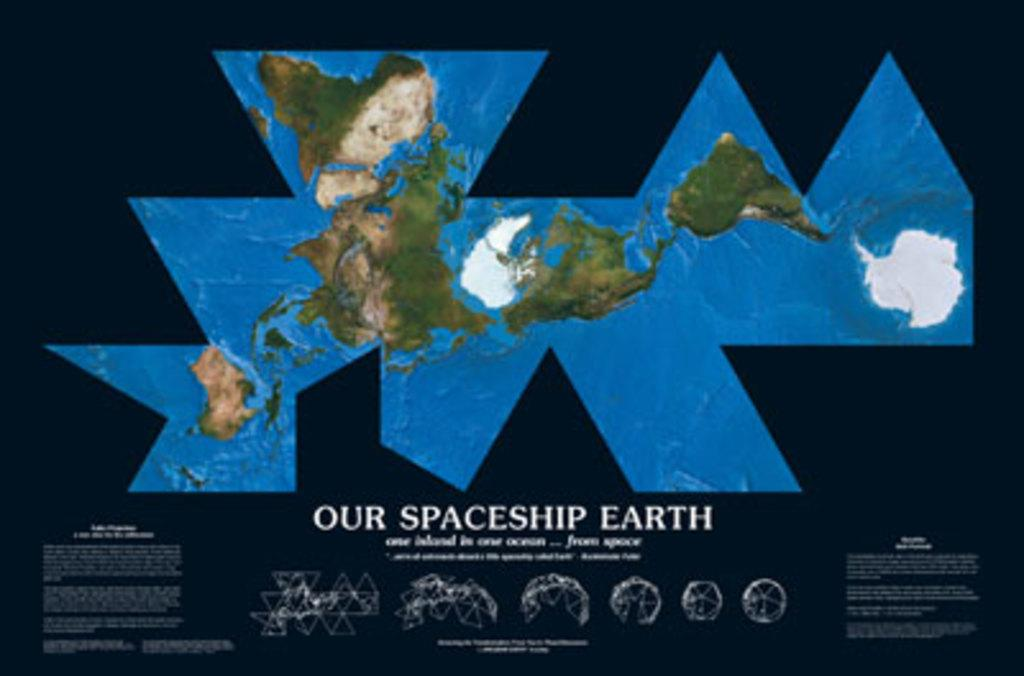<image>
Offer a succinct explanation of the picture presented. Our spaceship earth poster that includes a map 